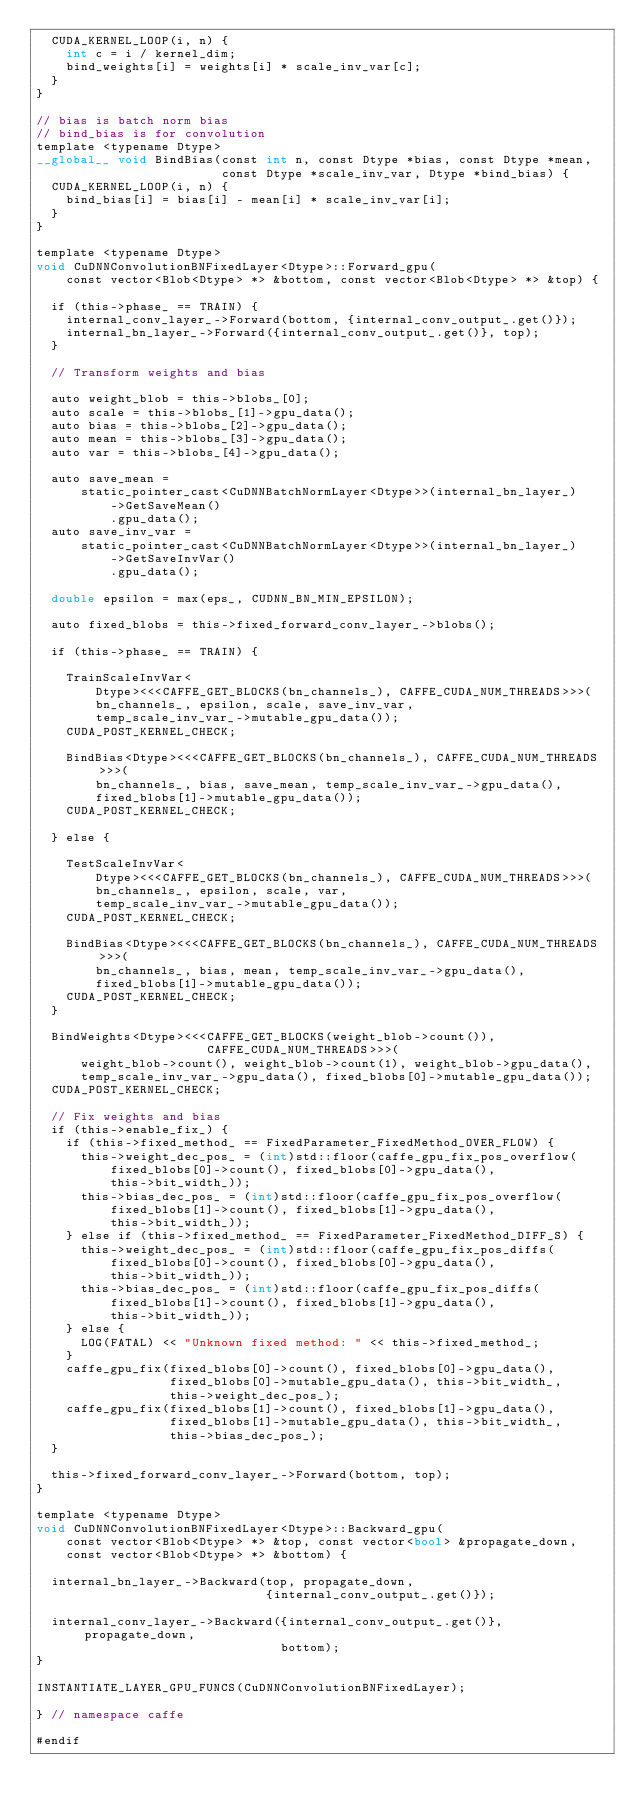<code> <loc_0><loc_0><loc_500><loc_500><_Cuda_>  CUDA_KERNEL_LOOP(i, n) {
    int c = i / kernel_dim;
    bind_weights[i] = weights[i] * scale_inv_var[c];
  }
}

// bias is batch norm bias
// bind_bias is for convolution
template <typename Dtype>
__global__ void BindBias(const int n, const Dtype *bias, const Dtype *mean,
                         const Dtype *scale_inv_var, Dtype *bind_bias) {
  CUDA_KERNEL_LOOP(i, n) {
    bind_bias[i] = bias[i] - mean[i] * scale_inv_var[i];
  }
}

template <typename Dtype>
void CuDNNConvolutionBNFixedLayer<Dtype>::Forward_gpu(
    const vector<Blob<Dtype> *> &bottom, const vector<Blob<Dtype> *> &top) {

  if (this->phase_ == TRAIN) {
    internal_conv_layer_->Forward(bottom, {internal_conv_output_.get()});
    internal_bn_layer_->Forward({internal_conv_output_.get()}, top);
  }

  // Transform weights and bias

  auto weight_blob = this->blobs_[0];
  auto scale = this->blobs_[1]->gpu_data();
  auto bias = this->blobs_[2]->gpu_data();
  auto mean = this->blobs_[3]->gpu_data();
  auto var = this->blobs_[4]->gpu_data();

  auto save_mean =
      static_pointer_cast<CuDNNBatchNormLayer<Dtype>>(internal_bn_layer_)
          ->GetSaveMean()
          .gpu_data();
  auto save_inv_var =
      static_pointer_cast<CuDNNBatchNormLayer<Dtype>>(internal_bn_layer_)
          ->GetSaveInvVar()
          .gpu_data();

  double epsilon = max(eps_, CUDNN_BN_MIN_EPSILON);

  auto fixed_blobs = this->fixed_forward_conv_layer_->blobs();

  if (this->phase_ == TRAIN) {

    TrainScaleInvVar<
        Dtype><<<CAFFE_GET_BLOCKS(bn_channels_), CAFFE_CUDA_NUM_THREADS>>>(
        bn_channels_, epsilon, scale, save_inv_var,
        temp_scale_inv_var_->mutable_gpu_data());
    CUDA_POST_KERNEL_CHECK;

    BindBias<Dtype><<<CAFFE_GET_BLOCKS(bn_channels_), CAFFE_CUDA_NUM_THREADS>>>(
        bn_channels_, bias, save_mean, temp_scale_inv_var_->gpu_data(),
        fixed_blobs[1]->mutable_gpu_data());
    CUDA_POST_KERNEL_CHECK;

  } else {

    TestScaleInvVar<
        Dtype><<<CAFFE_GET_BLOCKS(bn_channels_), CAFFE_CUDA_NUM_THREADS>>>(
        bn_channels_, epsilon, scale, var,
        temp_scale_inv_var_->mutable_gpu_data());
    CUDA_POST_KERNEL_CHECK;

    BindBias<Dtype><<<CAFFE_GET_BLOCKS(bn_channels_), CAFFE_CUDA_NUM_THREADS>>>(
        bn_channels_, bias, mean, temp_scale_inv_var_->gpu_data(),
        fixed_blobs[1]->mutable_gpu_data());
    CUDA_POST_KERNEL_CHECK;
  }

  BindWeights<Dtype><<<CAFFE_GET_BLOCKS(weight_blob->count()),
                       CAFFE_CUDA_NUM_THREADS>>>(
      weight_blob->count(), weight_blob->count(1), weight_blob->gpu_data(),
      temp_scale_inv_var_->gpu_data(), fixed_blobs[0]->mutable_gpu_data());
  CUDA_POST_KERNEL_CHECK;

  // Fix weights and bias
  if (this->enable_fix_) {
    if (this->fixed_method_ == FixedParameter_FixedMethod_OVER_FLOW) {
      this->weight_dec_pos_ = (int)std::floor(caffe_gpu_fix_pos_overflow(
          fixed_blobs[0]->count(), fixed_blobs[0]->gpu_data(),
          this->bit_width_));
      this->bias_dec_pos_ = (int)std::floor(caffe_gpu_fix_pos_overflow(
          fixed_blobs[1]->count(), fixed_blobs[1]->gpu_data(),
          this->bit_width_));
    } else if (this->fixed_method_ == FixedParameter_FixedMethod_DIFF_S) {
      this->weight_dec_pos_ = (int)std::floor(caffe_gpu_fix_pos_diffs(
          fixed_blobs[0]->count(), fixed_blobs[0]->gpu_data(),
          this->bit_width_));
      this->bias_dec_pos_ = (int)std::floor(caffe_gpu_fix_pos_diffs(
          fixed_blobs[1]->count(), fixed_blobs[1]->gpu_data(),
          this->bit_width_));
    } else {
      LOG(FATAL) << "Unknown fixed method: " << this->fixed_method_;
    }
    caffe_gpu_fix(fixed_blobs[0]->count(), fixed_blobs[0]->gpu_data(),
                  fixed_blobs[0]->mutable_gpu_data(), this->bit_width_,
                  this->weight_dec_pos_);
    caffe_gpu_fix(fixed_blobs[1]->count(), fixed_blobs[1]->gpu_data(),
                  fixed_blobs[1]->mutable_gpu_data(), this->bit_width_,
                  this->bias_dec_pos_);
  }

  this->fixed_forward_conv_layer_->Forward(bottom, top);
}

template <typename Dtype>
void CuDNNConvolutionBNFixedLayer<Dtype>::Backward_gpu(
    const vector<Blob<Dtype> *> &top, const vector<bool> &propagate_down,
    const vector<Blob<Dtype> *> &bottom) {

  internal_bn_layer_->Backward(top, propagate_down,
                               {internal_conv_output_.get()});

  internal_conv_layer_->Backward({internal_conv_output_.get()}, propagate_down,
                                 bottom);
}

INSTANTIATE_LAYER_GPU_FUNCS(CuDNNConvolutionBNFixedLayer);

} // namespace caffe

#endif
</code> 